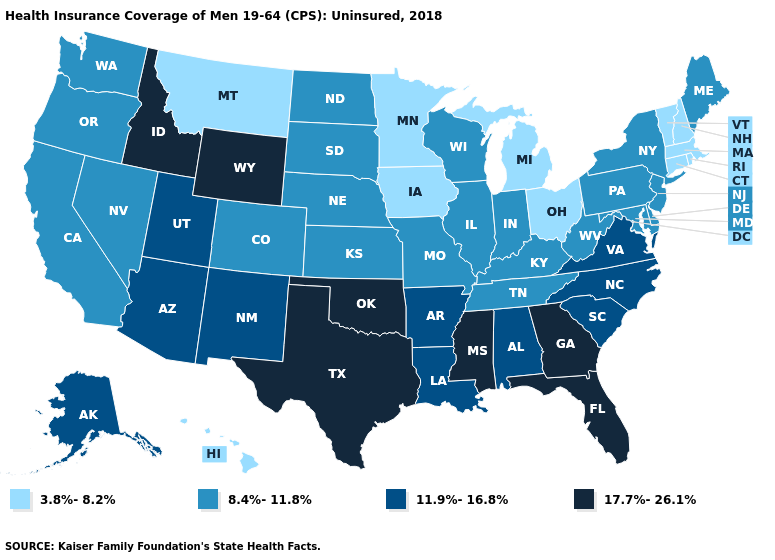How many symbols are there in the legend?
Give a very brief answer. 4. Which states hav the highest value in the MidWest?
Be succinct. Illinois, Indiana, Kansas, Missouri, Nebraska, North Dakota, South Dakota, Wisconsin. Which states have the lowest value in the South?
Give a very brief answer. Delaware, Kentucky, Maryland, Tennessee, West Virginia. What is the highest value in the West ?
Answer briefly. 17.7%-26.1%. Does Arizona have a higher value than Idaho?
Concise answer only. No. What is the value of Massachusetts?
Keep it brief. 3.8%-8.2%. Name the states that have a value in the range 11.9%-16.8%?
Keep it brief. Alabama, Alaska, Arizona, Arkansas, Louisiana, New Mexico, North Carolina, South Carolina, Utah, Virginia. Which states have the lowest value in the South?
Quick response, please. Delaware, Kentucky, Maryland, Tennessee, West Virginia. Name the states that have a value in the range 8.4%-11.8%?
Short answer required. California, Colorado, Delaware, Illinois, Indiana, Kansas, Kentucky, Maine, Maryland, Missouri, Nebraska, Nevada, New Jersey, New York, North Dakota, Oregon, Pennsylvania, South Dakota, Tennessee, Washington, West Virginia, Wisconsin. What is the value of Virginia?
Concise answer only. 11.9%-16.8%. Does New Hampshire have the highest value in the Northeast?
Give a very brief answer. No. What is the lowest value in the West?
Concise answer only. 3.8%-8.2%. Does New Hampshire have a higher value than Illinois?
Write a very short answer. No. Among the states that border Washington , which have the highest value?
Concise answer only. Idaho. Among the states that border Indiana , does Kentucky have the highest value?
Keep it brief. Yes. 